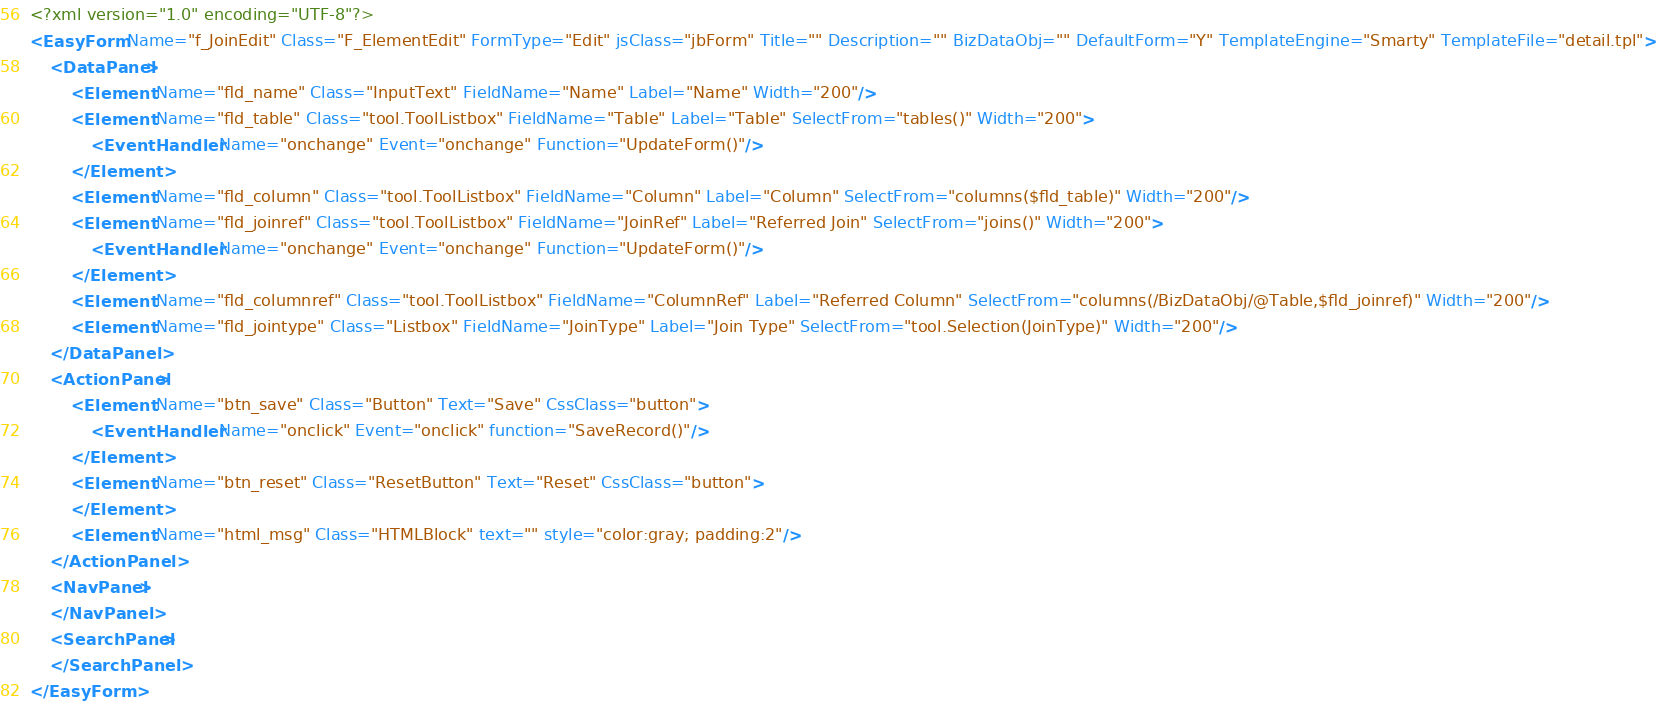<code> <loc_0><loc_0><loc_500><loc_500><_XML_><?xml version="1.0" encoding="UTF-8"?>
<EasyForm Name="f_JoinEdit" Class="F_ElementEdit" FormType="Edit" jsClass="jbForm" Title="" Description="" BizDataObj="" DefaultForm="Y" TemplateEngine="Smarty" TemplateFile="detail.tpl">
    <DataPanel>
        <Element Name="fld_name" Class="InputText" FieldName="Name" Label="Name" Width="200"/>
        <Element Name="fld_table" Class="tool.ToolListbox" FieldName="Table" Label="Table" SelectFrom="tables()" Width="200">
            <EventHandler Name="onchange" Event="onchange" Function="UpdateForm()"/>
        </Element>
        <Element Name="fld_column" Class="tool.ToolListbox" FieldName="Column" Label="Column" SelectFrom="columns($fld_table)" Width="200"/>
        <Element Name="fld_joinref" Class="tool.ToolListbox" FieldName="JoinRef" Label="Referred Join" SelectFrom="joins()" Width="200">
            <EventHandler Name="onchange" Event="onchange" Function="UpdateForm()"/>
        </Element>
        <Element Name="fld_columnref" Class="tool.ToolListbox" FieldName="ColumnRef" Label="Referred Column" SelectFrom="columns(/BizDataObj/@Table,$fld_joinref)" Width="200"/>
        <Element Name="fld_jointype" Class="Listbox" FieldName="JoinType" Label="Join Type" SelectFrom="tool.Selection(JoinType)" Width="200"/>
    </DataPanel>
    <ActionPanel>
        <Element Name="btn_save" Class="Button" Text="Save" CssClass="button">
            <EventHandler Name="onclick" Event="onclick" function="SaveRecord()"/>
        </Element>
        <Element Name="btn_reset" Class="ResetButton" Text="Reset" CssClass="button">
        </Element>
        <Element Name="html_msg" Class="HTMLBlock" text="" style="color:gray; padding:2"/>
    </ActionPanel> 
    <NavPanel>
    </NavPanel> 
    <SearchPanel>
    </SearchPanel>
</EasyForm>
</code> 